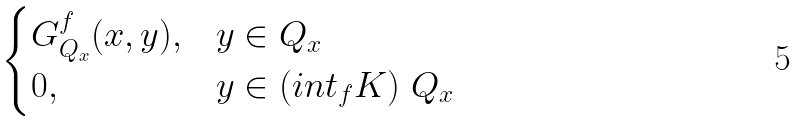Convert formula to latex. <formula><loc_0><loc_0><loc_500><loc_500>\begin{cases} G ^ { f } _ { Q _ { x } } ( x , y ) , & y \in Q _ { x } \\ 0 , & y \in ( i n t _ { f } K ) \ Q _ { x } \end{cases}</formula> 